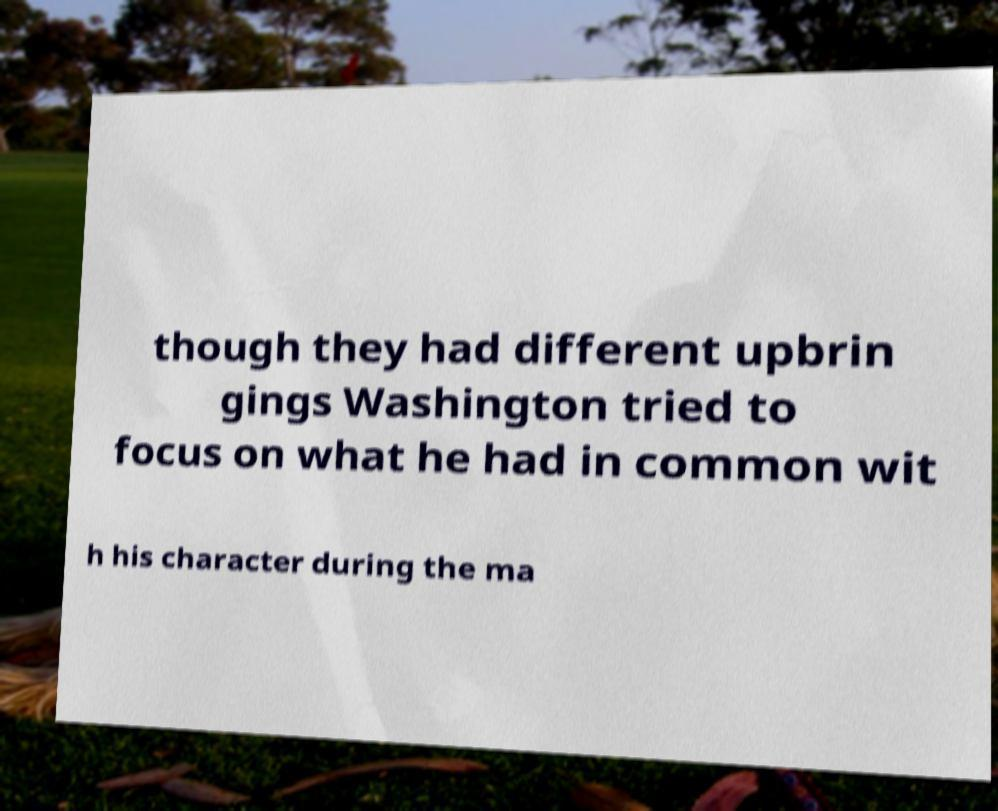I need the written content from this picture converted into text. Can you do that? though they had different upbrin gings Washington tried to focus on what he had in common wit h his character during the ma 